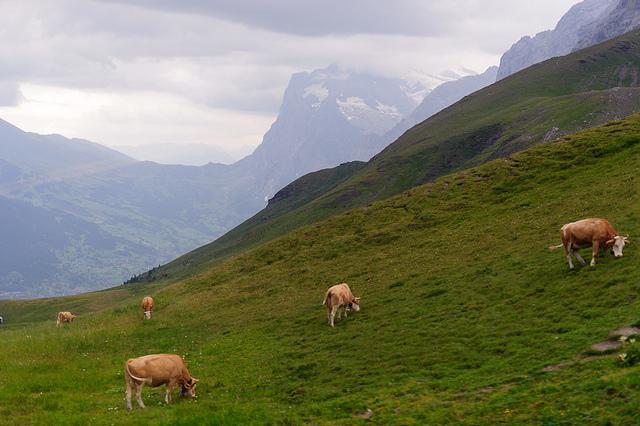What breed of cow is that?
Short answer required. Holstein. Are these animals standing still?
Write a very short answer. Yes. How many mountain ridges can be seen in the background?
Concise answer only. 3. Are all the cows standing?
Be succinct. Yes. Is it a nice day?
Write a very short answer. Yes. 